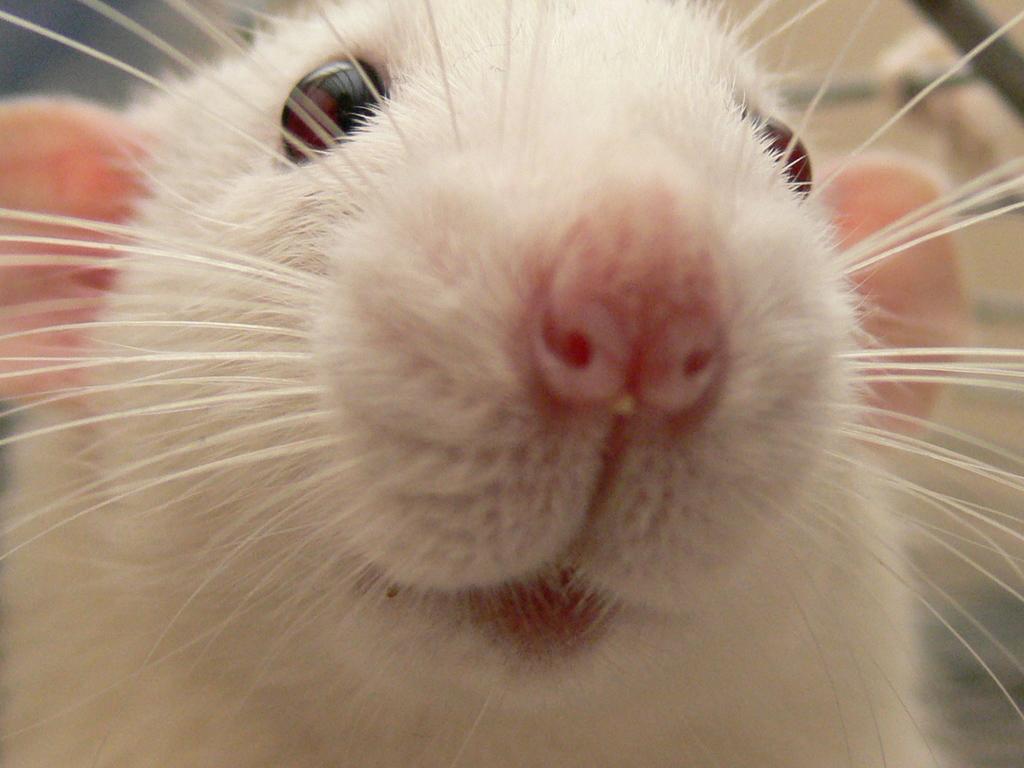Could you give a brief overview of what you see in this image? In this image we can see a white color rat and the background it is blurred. 